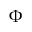<formula> <loc_0><loc_0><loc_500><loc_500>\Phi</formula> 